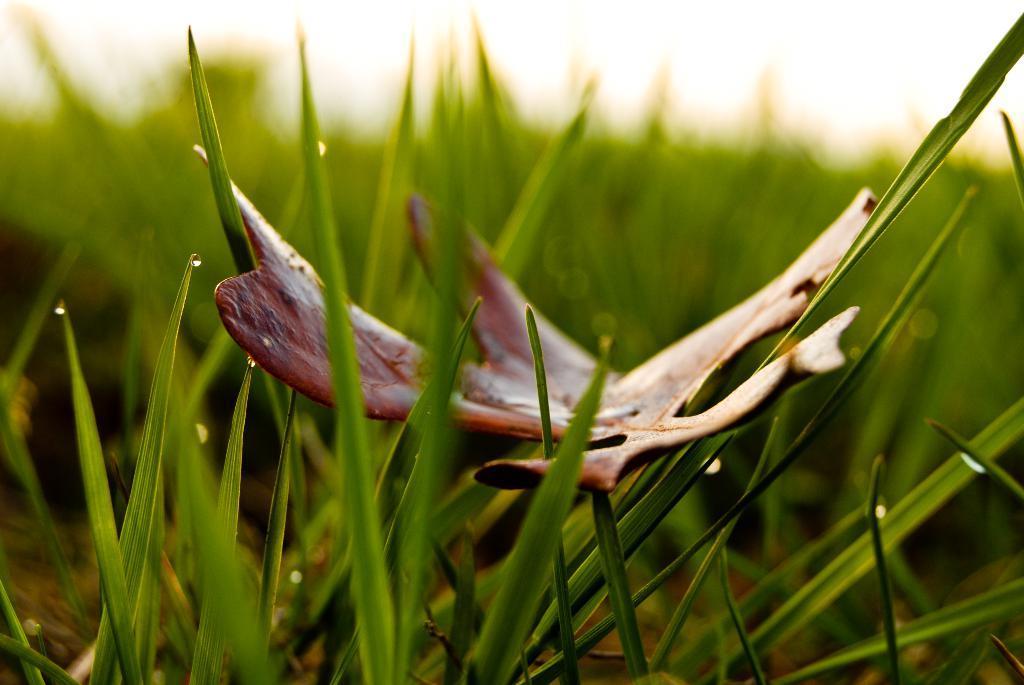Please provide a concise description of this image. In this picture I can see grass, there is a leaf, and there is blur background. 